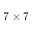Convert formula to latex. <formula><loc_0><loc_0><loc_500><loc_500>7 \times 7</formula> 